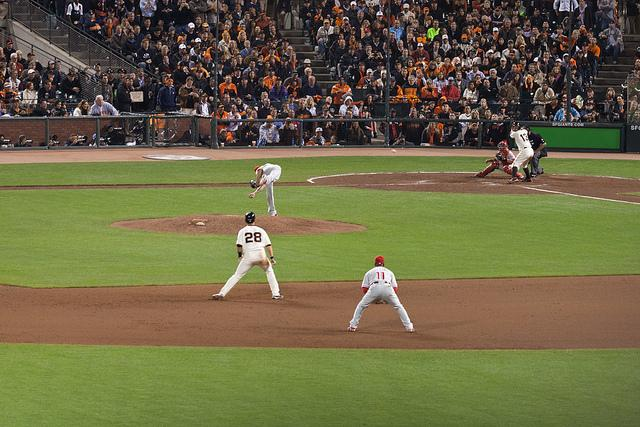Where does baseball come from?

Choices:
A) sweden
B) england
C) america
D) france france 